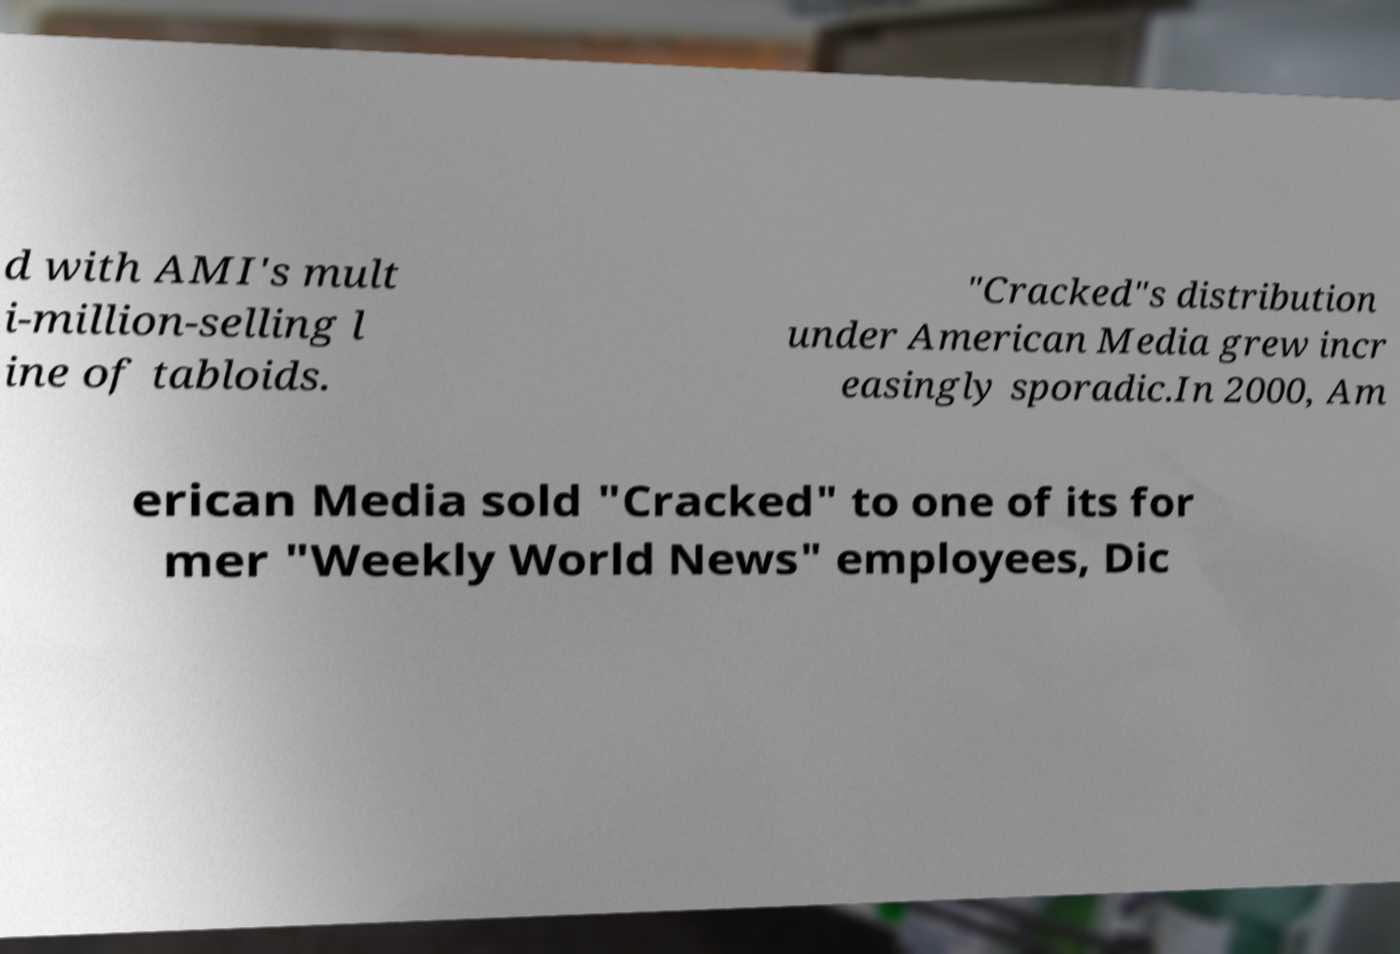Could you extract and type out the text from this image? d with AMI's mult i-million-selling l ine of tabloids. "Cracked"s distribution under American Media grew incr easingly sporadic.In 2000, Am erican Media sold "Cracked" to one of its for mer "Weekly World News" employees, Dic 